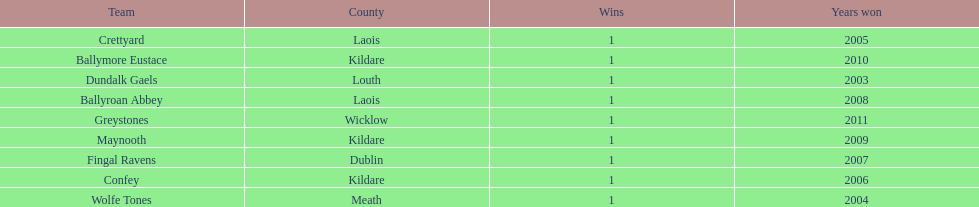Which team won previous to crettyard? Wolfe Tones. 